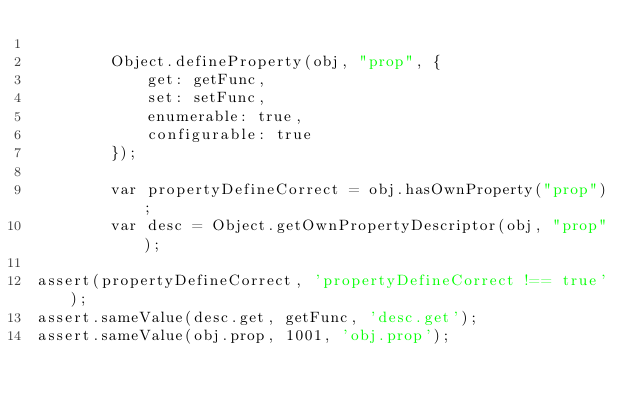Convert code to text. <code><loc_0><loc_0><loc_500><loc_500><_JavaScript_>
        Object.defineProperty(obj, "prop", {
            get: getFunc,
            set: setFunc,
            enumerable: true,
            configurable: true
        });

        var propertyDefineCorrect = obj.hasOwnProperty("prop");
        var desc = Object.getOwnPropertyDescriptor(obj, "prop");

assert(propertyDefineCorrect, 'propertyDefineCorrect !== true');
assert.sameValue(desc.get, getFunc, 'desc.get');
assert.sameValue(obj.prop, 1001, 'obj.prop');
</code> 